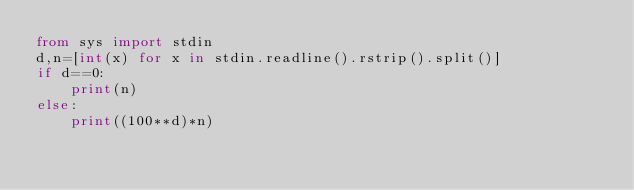<code> <loc_0><loc_0><loc_500><loc_500><_Python_>from sys import stdin
d,n=[int(x) for x in stdin.readline().rstrip().split()]
if d==0:
    print(n)
else:
    print((100**d)*n)</code> 